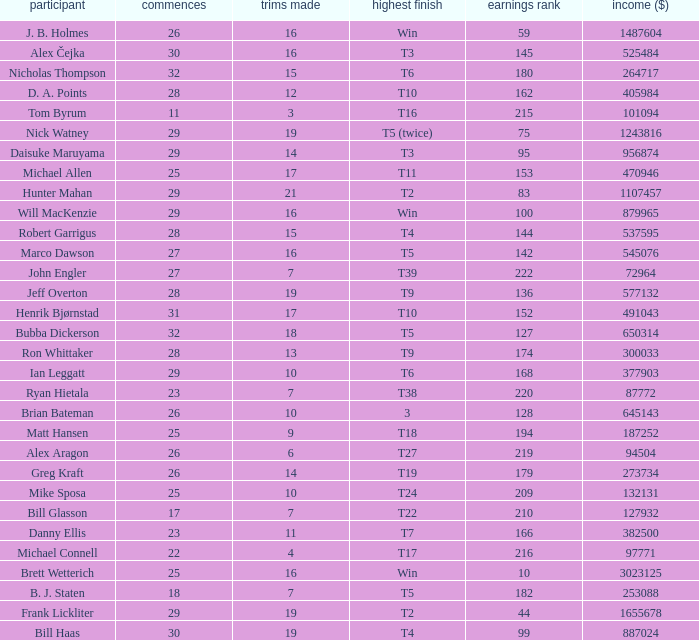Could you help me parse every detail presented in this table? {'header': ['participant', 'commences', 'trims made', 'highest finish', 'earnings rank', 'income ($)'], 'rows': [['J. B. Holmes', '26', '16', 'Win', '59', '1487604'], ['Alex Čejka', '30', '16', 'T3', '145', '525484'], ['Nicholas Thompson', '32', '15', 'T6', '180', '264717'], ['D. A. Points', '28', '12', 'T10', '162', '405984'], ['Tom Byrum', '11', '3', 'T16', '215', '101094'], ['Nick Watney', '29', '19', 'T5 (twice)', '75', '1243816'], ['Daisuke Maruyama', '29', '14', 'T3', '95', '956874'], ['Michael Allen', '25', '17', 'T11', '153', '470946'], ['Hunter Mahan', '29', '21', 'T2', '83', '1107457'], ['Will MacKenzie', '29', '16', 'Win', '100', '879965'], ['Robert Garrigus', '28', '15', 'T4', '144', '537595'], ['Marco Dawson', '27', '16', 'T5', '142', '545076'], ['John Engler', '27', '7', 'T39', '222', '72964'], ['Jeff Overton', '28', '19', 'T9', '136', '577132'], ['Henrik Bjørnstad', '31', '17', 'T10', '152', '491043'], ['Bubba Dickerson', '32', '18', 'T5', '127', '650314'], ['Ron Whittaker', '28', '13', 'T9', '174', '300033'], ['Ian Leggatt', '29', '10', 'T6', '168', '377903'], ['Ryan Hietala', '23', '7', 'T38', '220', '87772'], ['Brian Bateman', '26', '10', '3', '128', '645143'], ['Matt Hansen', '25', '9', 'T18', '194', '187252'], ['Alex Aragon', '26', '6', 'T27', '219', '94504'], ['Greg Kraft', '26', '14', 'T19', '179', '273734'], ['Mike Sposa', '25', '10', 'T24', '209', '132131'], ['Bill Glasson', '17', '7', 'T22', '210', '127932'], ['Danny Ellis', '23', '11', 'T7', '166', '382500'], ['Michael Connell', '22', '4', 'T17', '216', '97771'], ['Brett Wetterich', '25', '16', 'Win', '10', '3023125'], ['B. J. Staten', '18', '7', 'T5', '182', '253088'], ['Frank Lickliter', '29', '19', 'T2', '44', '1655678'], ['Bill Haas', '30', '19', 'T4', '99', '887024']]} What is the minimum number of cuts made for Hunter Mahan? 21.0. 